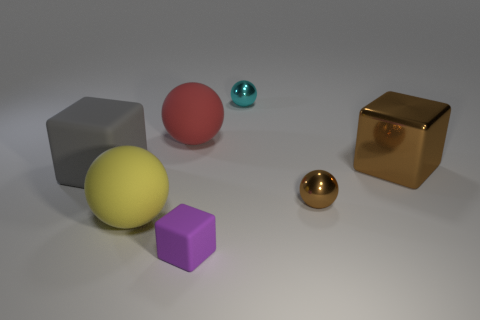There is a thing that is the same color as the metal cube; what shape is it?
Ensure brevity in your answer.  Sphere. There is a big brown metallic object; what number of small objects are in front of it?
Make the answer very short. 2. Are there any other cyan spheres of the same size as the cyan metal sphere?
Make the answer very short. No. What is the color of the other large thing that is the same shape as the big metallic object?
Offer a terse response. Gray. There is a rubber thing that is behind the large matte cube; is its size the same as the metallic sphere behind the tiny brown metal object?
Keep it short and to the point. No. Are there any other tiny objects that have the same shape as the gray thing?
Offer a terse response. Yes. Are there an equal number of cubes that are left of the brown cube and purple things?
Provide a succinct answer. No. There is a gray thing; is its size the same as the brown thing that is left of the big brown metal cube?
Offer a terse response. No. How many spheres are the same material as the red thing?
Make the answer very short. 1. Do the metallic block and the yellow rubber object have the same size?
Provide a succinct answer. Yes. 